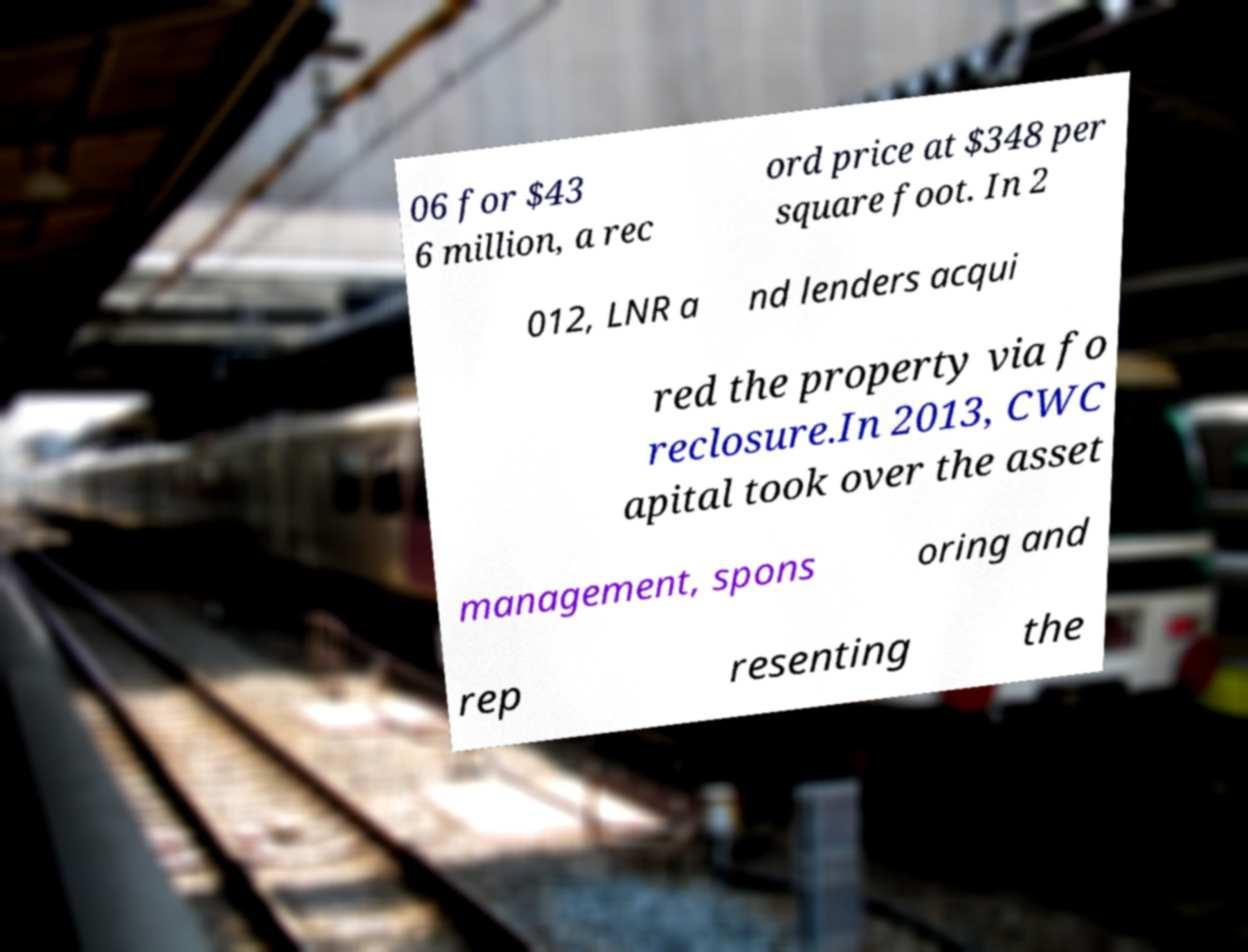I need the written content from this picture converted into text. Can you do that? 06 for $43 6 million, a rec ord price at $348 per square foot. In 2 012, LNR a nd lenders acqui red the property via fo reclosure.In 2013, CWC apital took over the asset management, spons oring and rep resenting the 